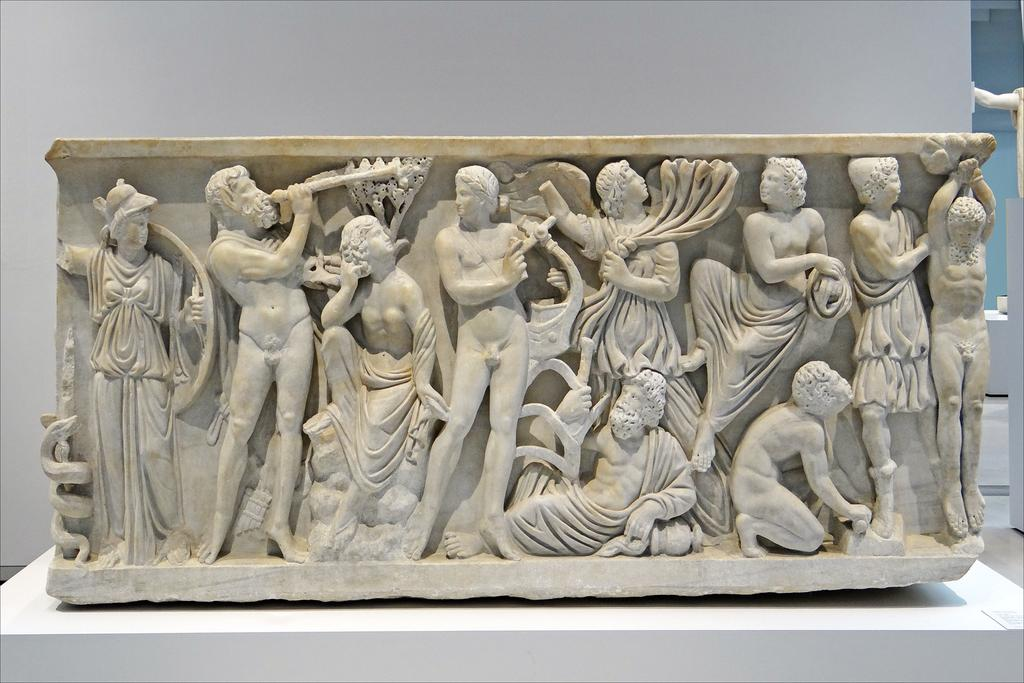What type of art is featured in the image? There are sculptures in the image. What is the color of the surface on which the sculptures are placed? The sculptures are on a white-colored surface. Can you describe the arrangement of the sculptures in the image? There is an additional sculpture on the right side of the image. What type of glove is being used to handle the sculptures in the image? There is no glove present in the image; the sculptures are on a white-colored surface. What type of furniture can be seen in the image? There is no furniture present in the image; the focus is on the sculptures and the white-colored surface. 